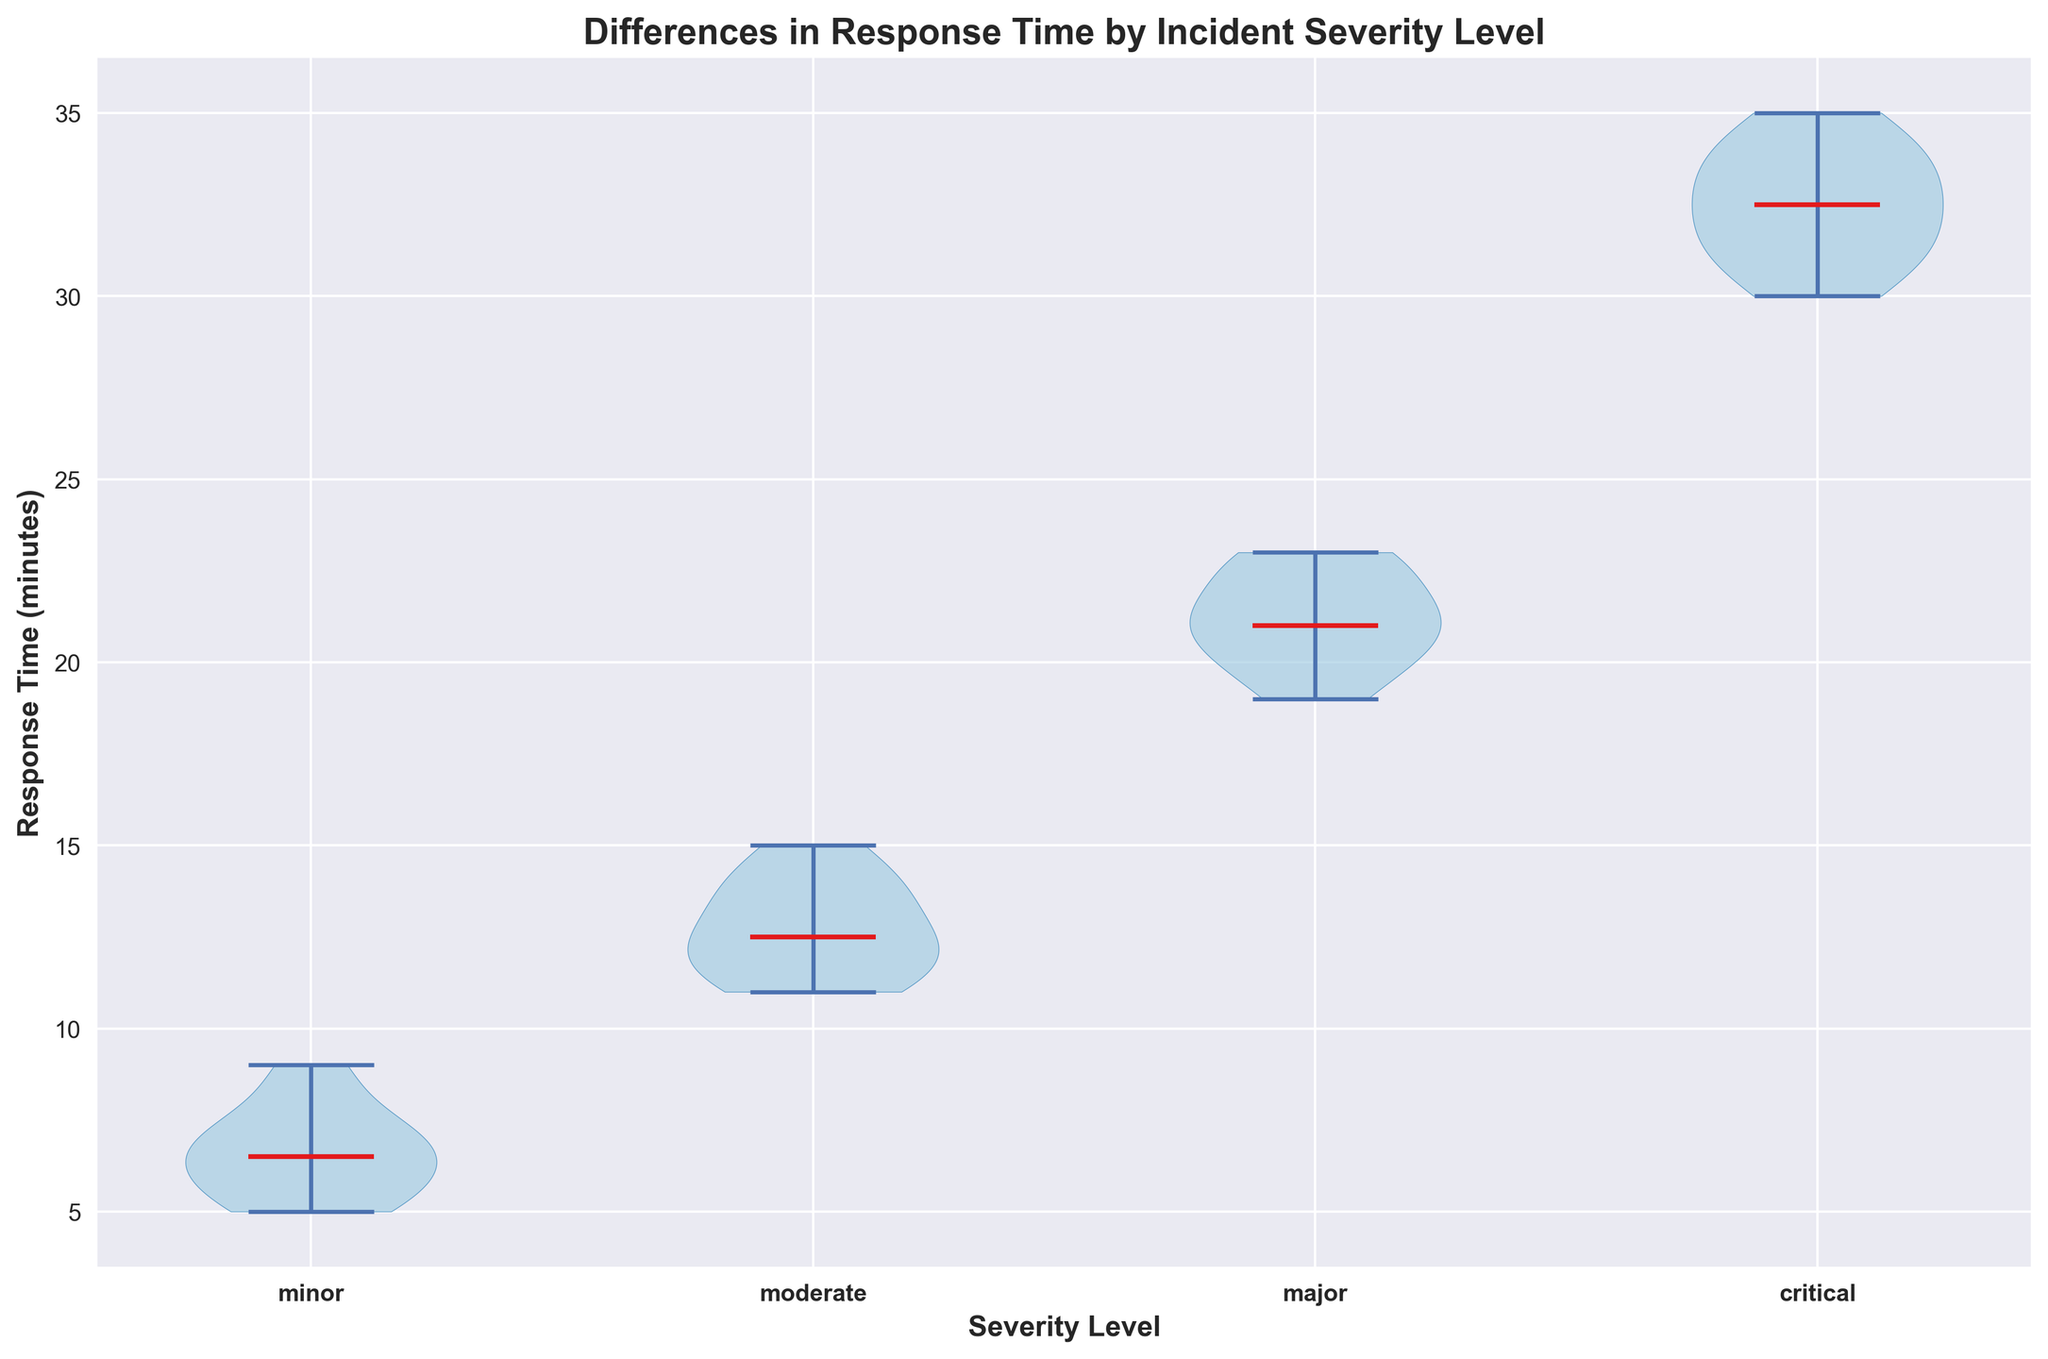What is the median response time for minor incidents? The median response time can be identified by the horizontal line within the violin plot section for minor incidents.
Answer: 7 Which severity level has the longest range of response times? The range of response times can be seen by comparing the vertical lengths of each violin. The critical severity level has the longest vertical length.
Answer: Critical How do the median response times compare between major and critical incidents? The median response times are marked by the horizontal line within each violin. By comparing the lines, the median for critical incidents is higher than for major incidents.
Answer: Critical has a higher median response time What are the visual differences in terms of spread and central tendency between moderate and major incidents? The spread is indicated by the width and length of the violins, while the central tendency is shown by the median line. The moderate incidents have a narrower spread and lower median compared to major incidents.
Answer: Moderate has a narrower spread and a lower median response time Looking at the plot, what is the approximate maximum response time for moderate incidents? The top boundary of the violin for moderate incidents shows the maximum response time, which can be estimated based on the axis.
Answer: Approximately 15 minutes Which severity level shows the least variability in response times? Variability can be assessed by the width of the violin plots. Thinner violins indicate lower variability. The minor severity level has the thinnest violin, indicating the least variability.
Answer: Minor How does the median response time for minor incidents compare to the median response time for critical incidents? By comparing the horizontal median lines of the violins for minor and critical incidents, the median for critical incidents is much higher.
Answer: Critical has a much higher median response time What is the approximate interquartile range (IQR) for major incidents? The IQR is a measure of the middle 50% of data points. It's indicated by the widest sections of the violin plot for major incidents, between the first and third quartiles. The range between these points can be estimated.
Answer: Approximately 20-23 minutes Do any of the severity levels show symmetrical distribution in response times? Symmetrical distribution in a violin plot is indicated when both sides of the violin are even. Minor incidents show a fairly symmetrical distribution.
Answer: Minor 